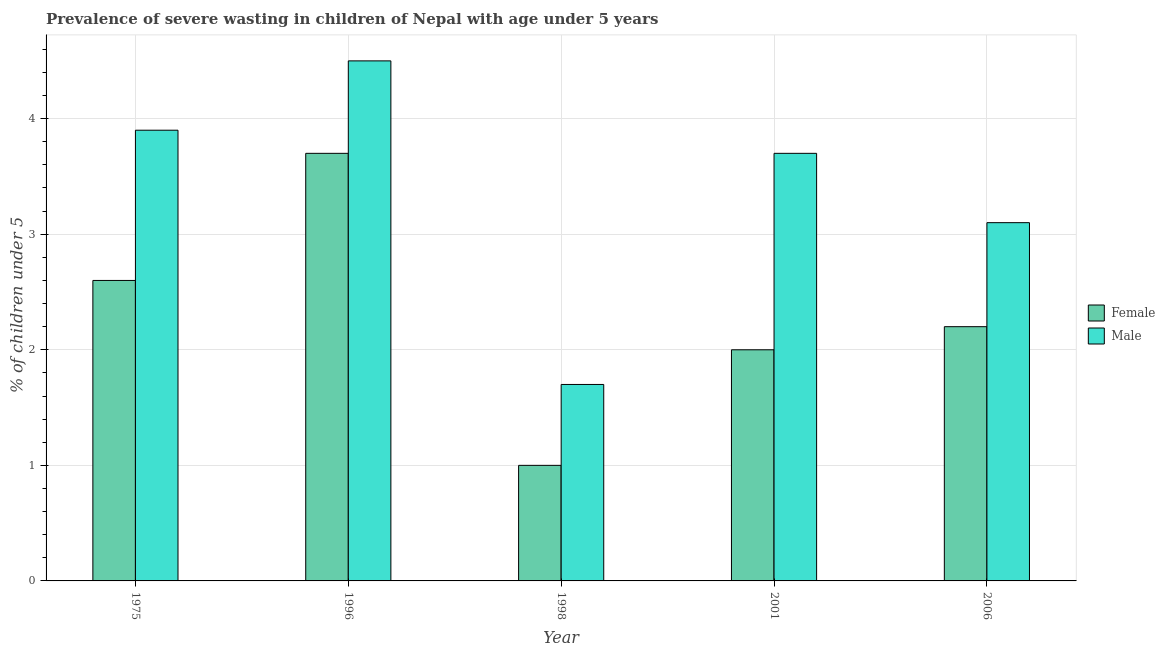How many groups of bars are there?
Your answer should be very brief. 5. Are the number of bars per tick equal to the number of legend labels?
Provide a succinct answer. Yes. How many bars are there on the 1st tick from the left?
Provide a short and direct response. 2. What is the label of the 2nd group of bars from the left?
Ensure brevity in your answer.  1996. What is the percentage of undernourished female children in 1996?
Give a very brief answer. 3.7. Across all years, what is the maximum percentage of undernourished female children?
Provide a succinct answer. 3.7. Across all years, what is the minimum percentage of undernourished male children?
Give a very brief answer. 1.7. In which year was the percentage of undernourished female children minimum?
Your answer should be very brief. 1998. What is the total percentage of undernourished female children in the graph?
Keep it short and to the point. 11.5. What is the difference between the percentage of undernourished male children in 1996 and that in 2001?
Keep it short and to the point. 0.8. What is the difference between the percentage of undernourished female children in 1998 and the percentage of undernourished male children in 2006?
Provide a short and direct response. -1.2. What is the average percentage of undernourished male children per year?
Your answer should be very brief. 3.38. What is the ratio of the percentage of undernourished male children in 1996 to that in 2006?
Offer a very short reply. 1.45. Is the difference between the percentage of undernourished male children in 1975 and 2006 greater than the difference between the percentage of undernourished female children in 1975 and 2006?
Your answer should be compact. No. What is the difference between the highest and the second highest percentage of undernourished male children?
Keep it short and to the point. 0.6. What is the difference between the highest and the lowest percentage of undernourished male children?
Offer a terse response. 2.8. What does the 1st bar from the right in 2001 represents?
Provide a short and direct response. Male. How many bars are there?
Provide a short and direct response. 10. How many years are there in the graph?
Give a very brief answer. 5. Are the values on the major ticks of Y-axis written in scientific E-notation?
Your answer should be compact. No. Does the graph contain any zero values?
Ensure brevity in your answer.  No. Where does the legend appear in the graph?
Make the answer very short. Center right. How many legend labels are there?
Your response must be concise. 2. How are the legend labels stacked?
Your response must be concise. Vertical. What is the title of the graph?
Ensure brevity in your answer.  Prevalence of severe wasting in children of Nepal with age under 5 years. What is the label or title of the Y-axis?
Your response must be concise.  % of children under 5. What is the  % of children under 5 of Female in 1975?
Provide a succinct answer. 2.6. What is the  % of children under 5 in Male in 1975?
Your answer should be very brief. 3.9. What is the  % of children under 5 of Female in 1996?
Make the answer very short. 3.7. What is the  % of children under 5 in Male in 1998?
Provide a short and direct response. 1.7. What is the  % of children under 5 in Male in 2001?
Your answer should be compact. 3.7. What is the  % of children under 5 of Female in 2006?
Ensure brevity in your answer.  2.2. What is the  % of children under 5 in Male in 2006?
Your response must be concise. 3.1. Across all years, what is the maximum  % of children under 5 in Female?
Provide a short and direct response. 3.7. Across all years, what is the minimum  % of children under 5 of Female?
Your answer should be compact. 1. Across all years, what is the minimum  % of children under 5 of Male?
Make the answer very short. 1.7. What is the total  % of children under 5 of Female in the graph?
Offer a terse response. 11.5. What is the difference between the  % of children under 5 in Female in 1975 and that in 1996?
Ensure brevity in your answer.  -1.1. What is the difference between the  % of children under 5 in Male in 1975 and that in 1996?
Ensure brevity in your answer.  -0.6. What is the difference between the  % of children under 5 in Female in 1975 and that in 2006?
Offer a terse response. 0.4. What is the difference between the  % of children under 5 in Female in 1996 and that in 1998?
Provide a short and direct response. 2.7. What is the difference between the  % of children under 5 in Female in 1996 and that in 2001?
Provide a short and direct response. 1.7. What is the difference between the  % of children under 5 of Female in 1998 and that in 2001?
Keep it short and to the point. -1. What is the difference between the  % of children under 5 in Male in 1998 and that in 2001?
Ensure brevity in your answer.  -2. What is the difference between the  % of children under 5 of Female in 2001 and that in 2006?
Give a very brief answer. -0.2. What is the difference between the  % of children under 5 of Female in 1975 and the  % of children under 5 of Male in 2001?
Provide a short and direct response. -1.1. What is the difference between the  % of children under 5 in Female in 1996 and the  % of children under 5 in Male in 2001?
Ensure brevity in your answer.  0. What is the difference between the  % of children under 5 of Female in 1996 and the  % of children under 5 of Male in 2006?
Give a very brief answer. 0.6. What is the difference between the  % of children under 5 of Female in 1998 and the  % of children under 5 of Male in 2006?
Keep it short and to the point. -2.1. What is the average  % of children under 5 of Female per year?
Provide a short and direct response. 2.3. What is the average  % of children under 5 in Male per year?
Give a very brief answer. 3.38. In the year 1975, what is the difference between the  % of children under 5 in Female and  % of children under 5 in Male?
Keep it short and to the point. -1.3. In the year 1996, what is the difference between the  % of children under 5 in Female and  % of children under 5 in Male?
Your answer should be very brief. -0.8. In the year 2001, what is the difference between the  % of children under 5 in Female and  % of children under 5 in Male?
Make the answer very short. -1.7. In the year 2006, what is the difference between the  % of children under 5 in Female and  % of children under 5 in Male?
Your answer should be very brief. -0.9. What is the ratio of the  % of children under 5 of Female in 1975 to that in 1996?
Offer a very short reply. 0.7. What is the ratio of the  % of children under 5 in Male in 1975 to that in 1996?
Your answer should be compact. 0.87. What is the ratio of the  % of children under 5 in Female in 1975 to that in 1998?
Your response must be concise. 2.6. What is the ratio of the  % of children under 5 of Male in 1975 to that in 1998?
Provide a short and direct response. 2.29. What is the ratio of the  % of children under 5 in Female in 1975 to that in 2001?
Give a very brief answer. 1.3. What is the ratio of the  % of children under 5 in Male in 1975 to that in 2001?
Offer a terse response. 1.05. What is the ratio of the  % of children under 5 of Female in 1975 to that in 2006?
Give a very brief answer. 1.18. What is the ratio of the  % of children under 5 of Male in 1975 to that in 2006?
Keep it short and to the point. 1.26. What is the ratio of the  % of children under 5 in Male in 1996 to that in 1998?
Your answer should be compact. 2.65. What is the ratio of the  % of children under 5 in Female in 1996 to that in 2001?
Provide a short and direct response. 1.85. What is the ratio of the  % of children under 5 in Male in 1996 to that in 2001?
Your answer should be very brief. 1.22. What is the ratio of the  % of children under 5 in Female in 1996 to that in 2006?
Provide a succinct answer. 1.68. What is the ratio of the  % of children under 5 of Male in 1996 to that in 2006?
Your response must be concise. 1.45. What is the ratio of the  % of children under 5 in Female in 1998 to that in 2001?
Offer a terse response. 0.5. What is the ratio of the  % of children under 5 of Male in 1998 to that in 2001?
Give a very brief answer. 0.46. What is the ratio of the  % of children under 5 in Female in 1998 to that in 2006?
Your answer should be very brief. 0.45. What is the ratio of the  % of children under 5 of Male in 1998 to that in 2006?
Make the answer very short. 0.55. What is the ratio of the  % of children under 5 of Female in 2001 to that in 2006?
Provide a short and direct response. 0.91. What is the ratio of the  % of children under 5 of Male in 2001 to that in 2006?
Make the answer very short. 1.19. 